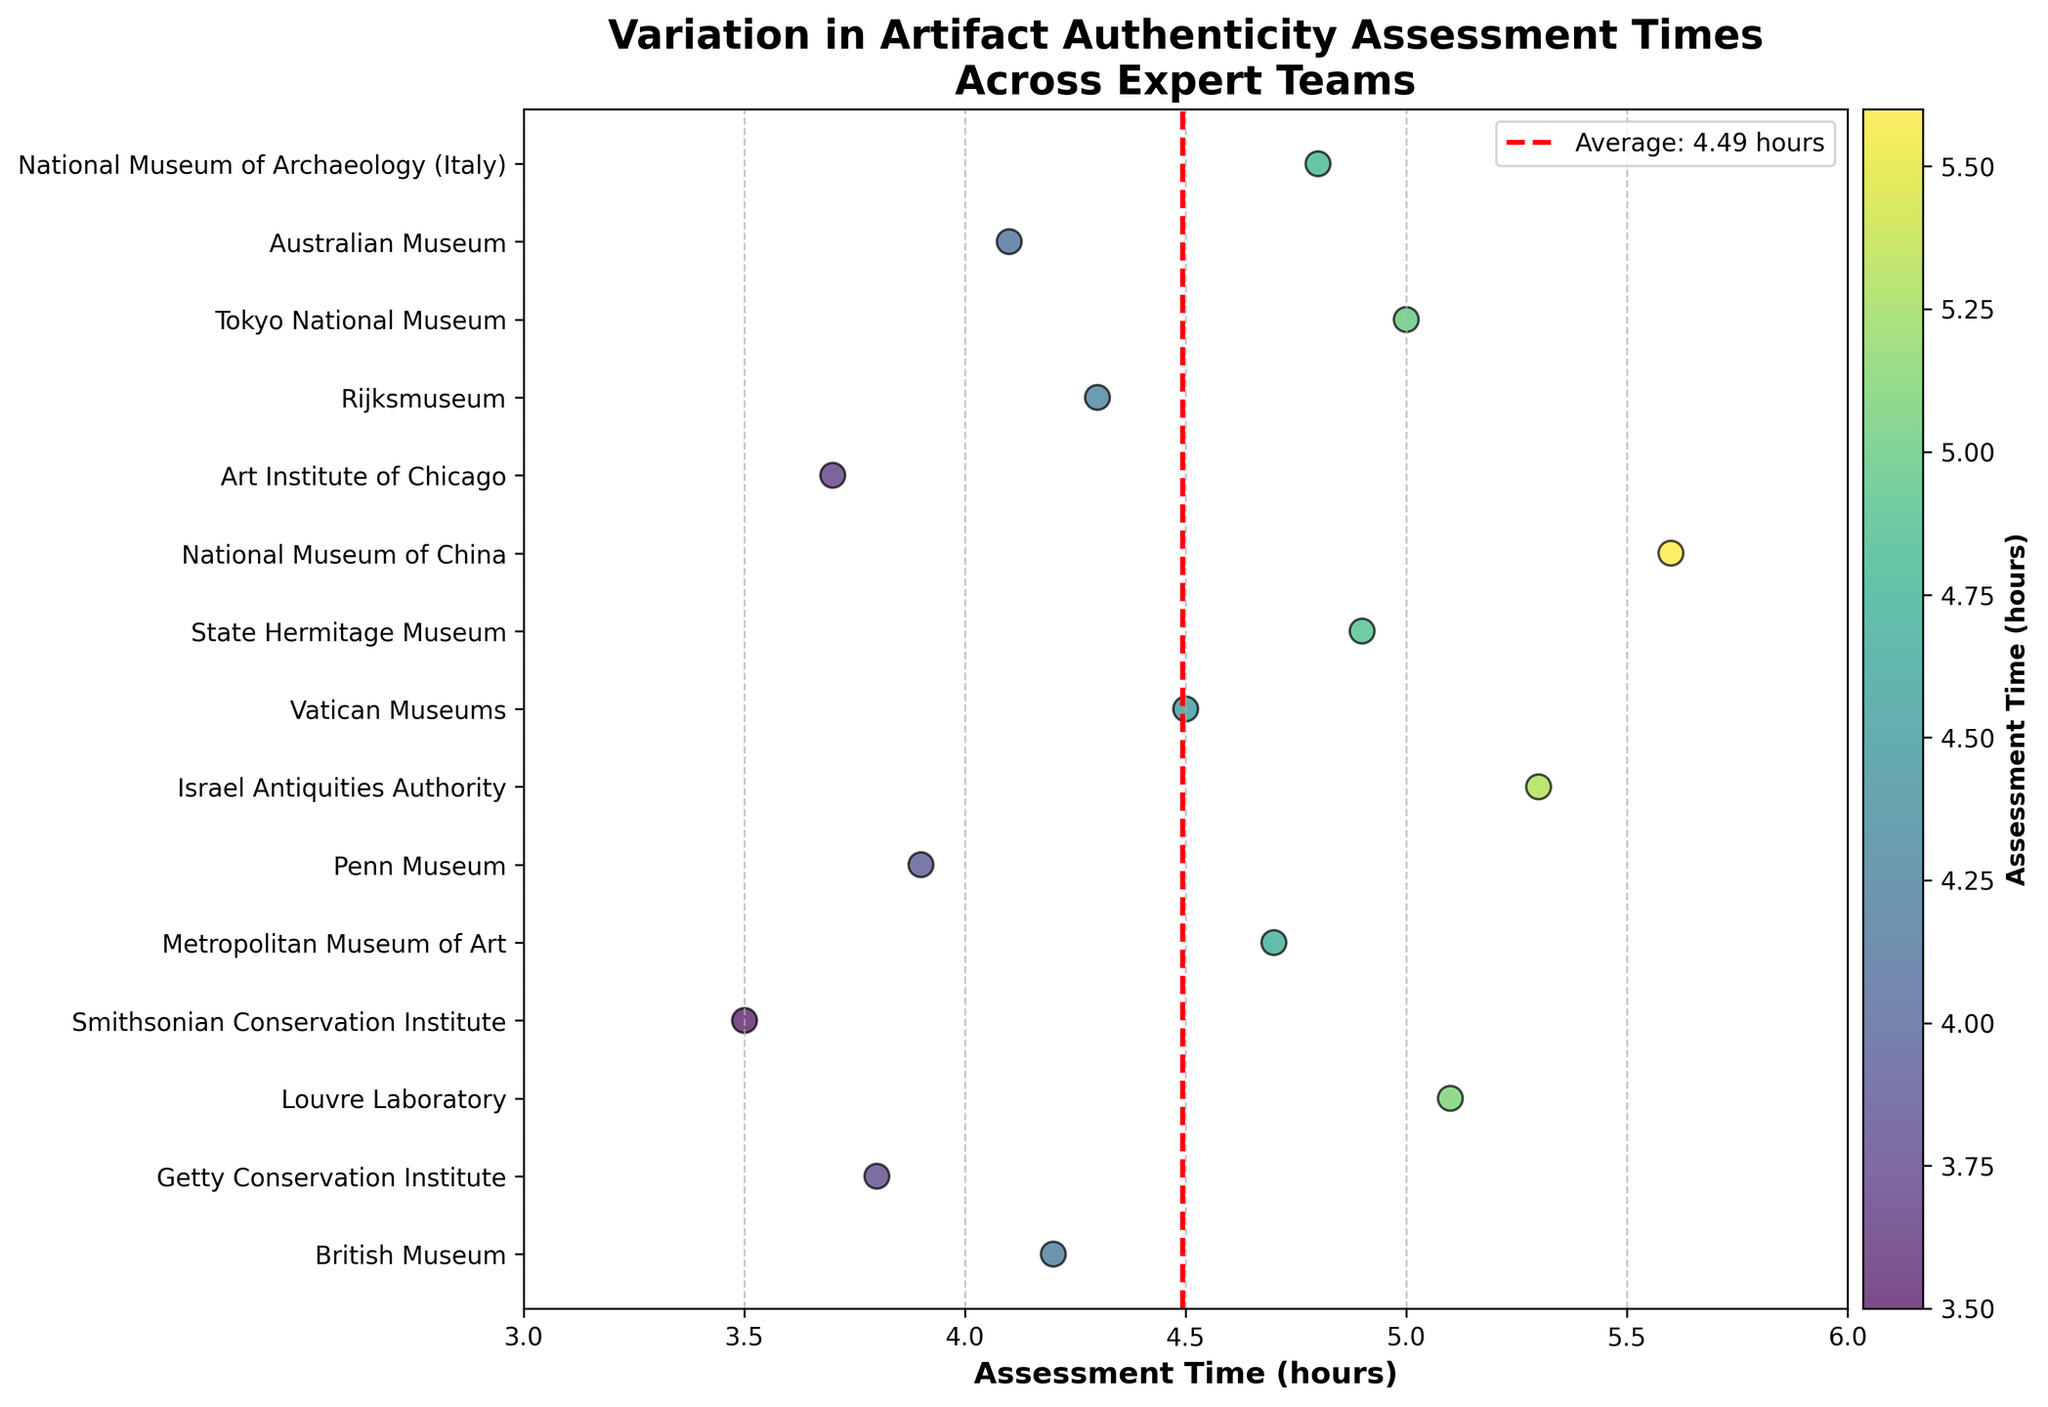What is the title of the plot? The title of the plot is displayed at the top of the figure.
Answer: Variation in Artifact Authenticity Assessment Times Across Expert Teams Which team has the shortest assessment time? By looking at the strip plot, the team with the lowest (leftmost) point represents the shortest assessment time.
Answer: Smithsonian Conservation Institute What is the assessment time for the British Museum team? Locate the British Museum label on the y-axis and refer to the corresponding dot on the x-axis.
Answer: 4.2 hours How many teams have an assessment time of 4.0 hours or above? Count the number of points on the x-axis that are at 4.0 hours or more.
Answer: 11 teams Which teams have assessment times greater than 5.0 hours? Identify points to the right of the x-axis at 5.0 hours and list the corresponding teams.
Answer: Louvre Laboratory, Israel Antiquities Authority, National Museum of China, Tokyo National Museum What is the average assessment time across all expert teams? The plot has a red dashed vertical line that represents the average assessment time. Read the value where the line intersects the x-axis.
Answer: 4.51 hours What is the difference in assessment times between the Australian Museum and the National Museum of China? Find the assessment times for both teams, then subtract the smaller value from the larger one.
Answer: 1.5 hours Which team appears to take exactly 5.0 hours for assessment? Look for the point that corresponds to 5.0 hours on the x-axis and check the y-axis label for the team.
Answer: Tokyo National Museum Are there any teams with assessment times below the average? If so, which ones? Find points to the left of the red dashed average line, and note the corresponding teams.
Answer: Getty Conservation Institute, Smithsonian Conservation Institute, Penn Museum, Art Institute of Chicago, Australian Museum What color corresponds to the highest assessment times on the colorbar? Examine the colorbar on the right side of the plot to identify the color representing the highest value.
Answer: Dark yellow 